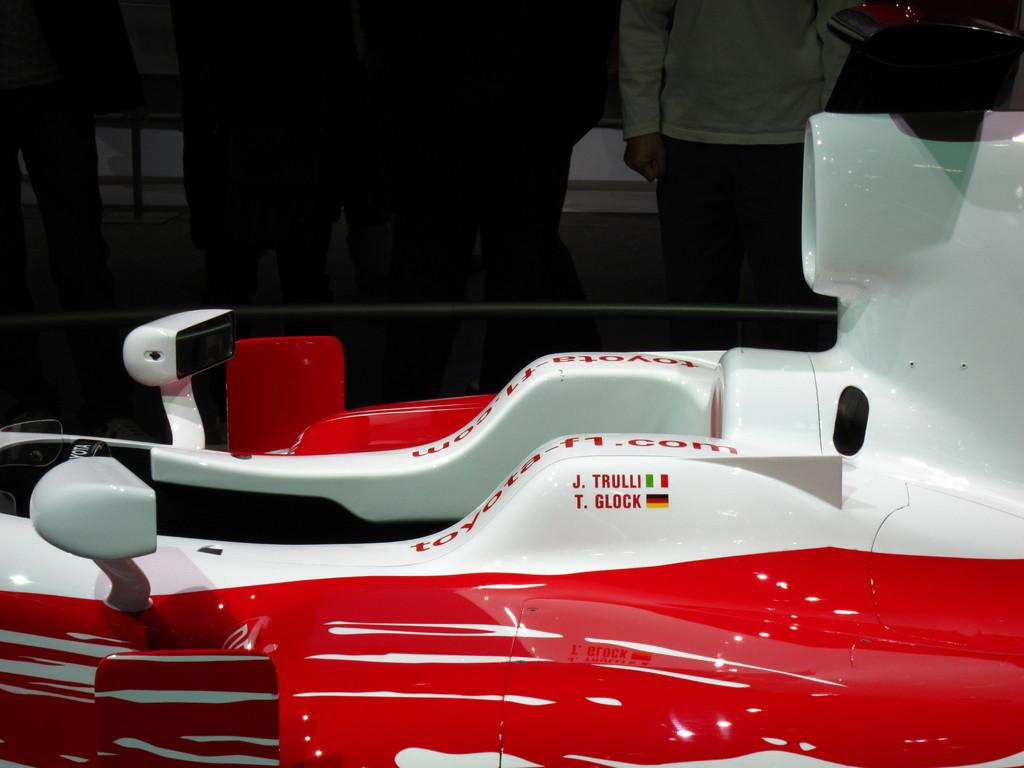What is the color of the object in the picture? The object in the picture has a red and white color. What can be seen in the background of the picture? People are standing in the background of the picture. Is there any text or symbols on the object? Yes, there is writing on the object. What type of meal is being prepared in the picture? There is no meal preparation visible in the picture. Is there any fiction being read by the people in the background? The image does not show any books or reading material, so it cannot be determined if fiction is being read. 